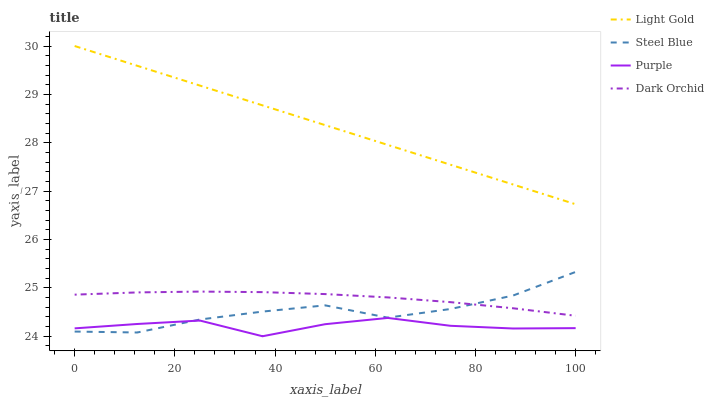Does Steel Blue have the minimum area under the curve?
Answer yes or no. No. Does Steel Blue have the maximum area under the curve?
Answer yes or no. No. Is Steel Blue the smoothest?
Answer yes or no. No. Is Steel Blue the roughest?
Answer yes or no. No. Does Steel Blue have the lowest value?
Answer yes or no. No. Does Steel Blue have the highest value?
Answer yes or no. No. Is Purple less than Dark Orchid?
Answer yes or no. Yes. Is Light Gold greater than Dark Orchid?
Answer yes or no. Yes. Does Purple intersect Dark Orchid?
Answer yes or no. No. 